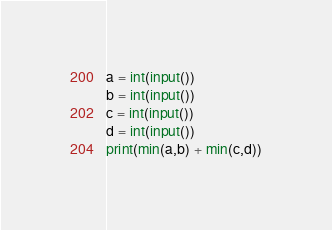<code> <loc_0><loc_0><loc_500><loc_500><_Python_>a = int(input())
b = int(input())
c = int(input())
d = int(input())
print(min(a,b) + min(c,d))</code> 